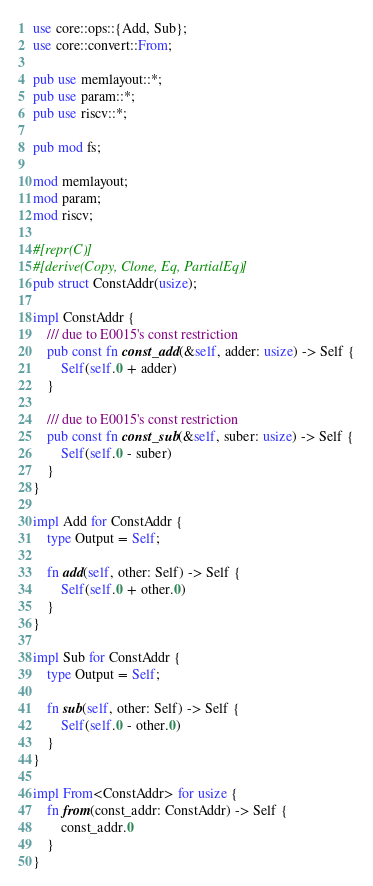Convert code to text. <code><loc_0><loc_0><loc_500><loc_500><_Rust_>use core::ops::{Add, Sub};
use core::convert::From;

pub use memlayout::*;
pub use param::*;
pub use riscv::*;

pub mod fs;

mod memlayout;
mod param;
mod riscv;

#[repr(C)]
#[derive(Copy, Clone, Eq, PartialEq)]
pub struct ConstAddr(usize);

impl ConstAddr {
    /// due to E0015's const restriction
    pub const fn const_add(&self, adder: usize) -> Self {
        Self(self.0 + adder)
    }

    /// due to E0015's const restriction
    pub const fn const_sub(&self, suber: usize) -> Self {
        Self(self.0 - suber)
    }
}

impl Add for ConstAddr {
    type Output = Self;

    fn add(self, other: Self) -> Self {
        Self(self.0 + other.0)
    }
}

impl Sub for ConstAddr {
    type Output = Self;

    fn sub(self, other: Self) -> Self {
        Self(self.0 - other.0)
    }
}

impl From<ConstAddr> for usize {
    fn from(const_addr: ConstAddr) -> Self {
        const_addr.0
    }
}
</code> 